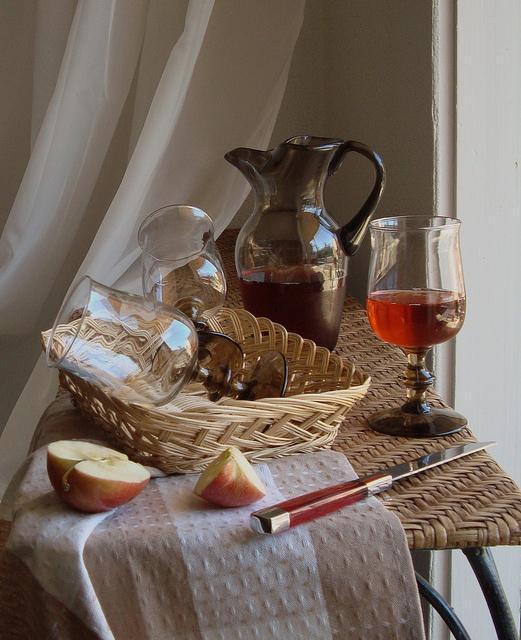How many glasses are in the picture?
Give a very brief answer. 3. How many wine glasses are there?
Give a very brief answer. 3. How many apples are there?
Give a very brief answer. 2. 